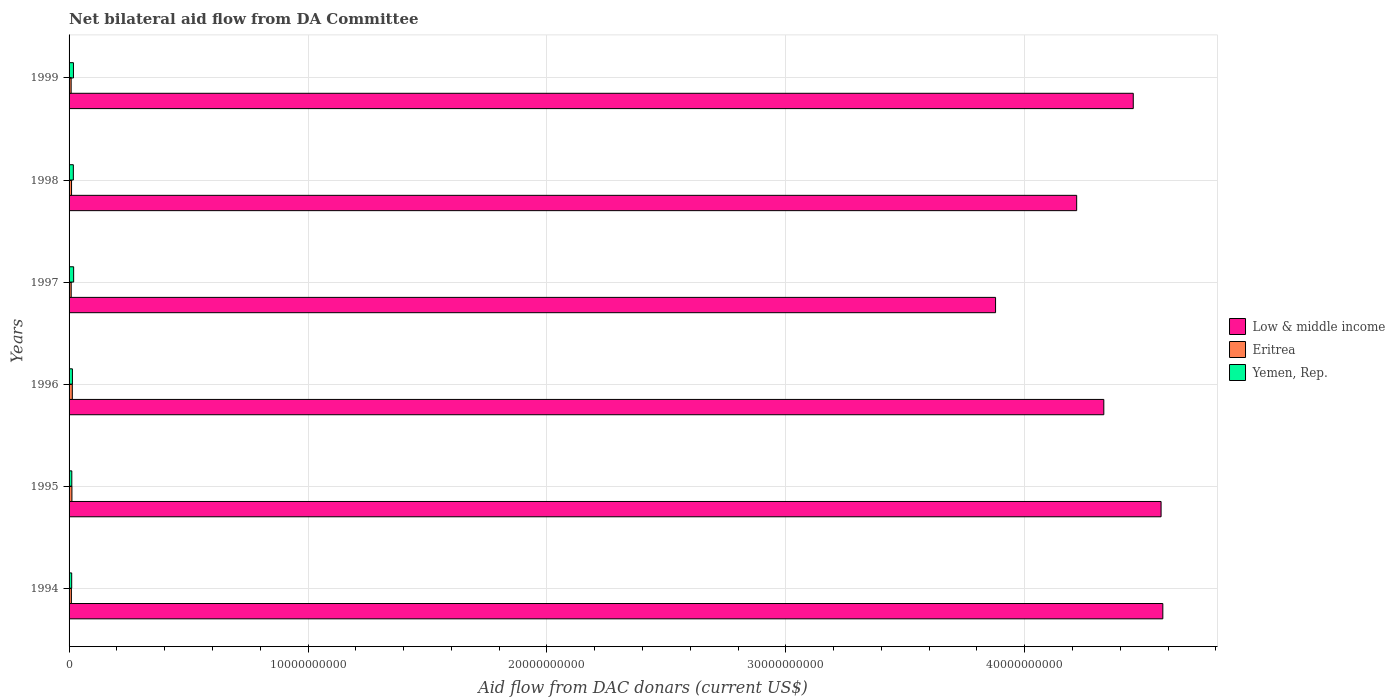How many groups of bars are there?
Offer a very short reply. 6. Are the number of bars on each tick of the Y-axis equal?
Make the answer very short. Yes. How many bars are there on the 6th tick from the top?
Offer a very short reply. 3. What is the label of the 1st group of bars from the top?
Provide a succinct answer. 1999. What is the aid flow in in Eritrea in 1994?
Your answer should be compact. 9.72e+07. Across all years, what is the maximum aid flow in in Eritrea?
Your answer should be very brief. 1.36e+08. Across all years, what is the minimum aid flow in in Eritrea?
Give a very brief answer. 8.65e+07. In which year was the aid flow in in Low & middle income maximum?
Your answer should be very brief. 1994. What is the total aid flow in in Yemen, Rep. in the graph?
Offer a terse response. 9.18e+08. What is the difference between the aid flow in in Low & middle income in 1994 and that in 1998?
Provide a succinct answer. 3.61e+09. What is the difference between the aid flow in in Yemen, Rep. in 1994 and the aid flow in in Eritrea in 1998?
Offer a terse response. 6.26e+06. What is the average aid flow in in Eritrea per year?
Give a very brief answer. 1.05e+08. In the year 1998, what is the difference between the aid flow in in Yemen, Rep. and aid flow in in Eritrea?
Provide a short and direct response. 7.51e+07. In how many years, is the aid flow in in Yemen, Rep. greater than 34000000000 US$?
Provide a succinct answer. 0. What is the ratio of the aid flow in in Eritrea in 1994 to that in 1999?
Your answer should be very brief. 1.12. Is the difference between the aid flow in in Yemen, Rep. in 1995 and 1999 greater than the difference between the aid flow in in Eritrea in 1995 and 1999?
Your response must be concise. No. What is the difference between the highest and the second highest aid flow in in Yemen, Rep.?
Provide a short and direct response. 7.62e+06. What is the difference between the highest and the lowest aid flow in in Yemen, Rep.?
Keep it short and to the point. 8.14e+07. In how many years, is the aid flow in in Low & middle income greater than the average aid flow in in Low & middle income taken over all years?
Your answer should be very brief. 3. Is the sum of the aid flow in in Yemen, Rep. in 1997 and 1998 greater than the maximum aid flow in in Low & middle income across all years?
Your answer should be very brief. No. What does the 2nd bar from the top in 1995 represents?
Give a very brief answer. Eritrea. What does the 3rd bar from the bottom in 1997 represents?
Make the answer very short. Yemen, Rep. How many years are there in the graph?
Offer a very short reply. 6. Does the graph contain grids?
Provide a succinct answer. Yes. How many legend labels are there?
Your response must be concise. 3. What is the title of the graph?
Give a very brief answer. Net bilateral aid flow from DA Committee. What is the label or title of the X-axis?
Ensure brevity in your answer.  Aid flow from DAC donars (current US$). What is the label or title of the Y-axis?
Provide a short and direct response. Years. What is the Aid flow from DAC donars (current US$) in Low & middle income in 1994?
Offer a terse response. 4.58e+1. What is the Aid flow from DAC donars (current US$) of Eritrea in 1994?
Provide a short and direct response. 9.72e+07. What is the Aid flow from DAC donars (current US$) of Yemen, Rep. in 1994?
Make the answer very short. 1.10e+08. What is the Aid flow from DAC donars (current US$) of Low & middle income in 1995?
Provide a short and direct response. 4.57e+1. What is the Aid flow from DAC donars (current US$) in Eritrea in 1995?
Ensure brevity in your answer.  1.19e+08. What is the Aid flow from DAC donars (current US$) of Yemen, Rep. in 1995?
Provide a succinct answer. 1.15e+08. What is the Aid flow from DAC donars (current US$) of Low & middle income in 1996?
Make the answer very short. 4.33e+1. What is the Aid flow from DAC donars (current US$) of Eritrea in 1996?
Make the answer very short. 1.36e+08. What is the Aid flow from DAC donars (current US$) of Yemen, Rep. in 1996?
Make the answer very short. 1.40e+08. What is the Aid flow from DAC donars (current US$) of Low & middle income in 1997?
Give a very brief answer. 3.88e+1. What is the Aid flow from DAC donars (current US$) in Eritrea in 1997?
Give a very brief answer. 8.83e+07. What is the Aid flow from DAC donars (current US$) of Yemen, Rep. in 1997?
Your response must be concise. 1.91e+08. What is the Aid flow from DAC donars (current US$) of Low & middle income in 1998?
Keep it short and to the point. 4.22e+1. What is the Aid flow from DAC donars (current US$) of Eritrea in 1998?
Give a very brief answer. 1.04e+08. What is the Aid flow from DAC donars (current US$) in Yemen, Rep. in 1998?
Your response must be concise. 1.79e+08. What is the Aid flow from DAC donars (current US$) in Low & middle income in 1999?
Offer a terse response. 4.45e+1. What is the Aid flow from DAC donars (current US$) of Eritrea in 1999?
Offer a very short reply. 8.65e+07. What is the Aid flow from DAC donars (current US$) of Yemen, Rep. in 1999?
Offer a terse response. 1.84e+08. Across all years, what is the maximum Aid flow from DAC donars (current US$) of Low & middle income?
Offer a very short reply. 4.58e+1. Across all years, what is the maximum Aid flow from DAC donars (current US$) of Eritrea?
Ensure brevity in your answer.  1.36e+08. Across all years, what is the maximum Aid flow from DAC donars (current US$) in Yemen, Rep.?
Keep it short and to the point. 1.91e+08. Across all years, what is the minimum Aid flow from DAC donars (current US$) of Low & middle income?
Ensure brevity in your answer.  3.88e+1. Across all years, what is the minimum Aid flow from DAC donars (current US$) in Eritrea?
Offer a terse response. 8.65e+07. Across all years, what is the minimum Aid flow from DAC donars (current US$) in Yemen, Rep.?
Your response must be concise. 1.10e+08. What is the total Aid flow from DAC donars (current US$) of Low & middle income in the graph?
Keep it short and to the point. 2.60e+11. What is the total Aid flow from DAC donars (current US$) of Eritrea in the graph?
Your answer should be very brief. 6.31e+08. What is the total Aid flow from DAC donars (current US$) of Yemen, Rep. in the graph?
Offer a terse response. 9.18e+08. What is the difference between the Aid flow from DAC donars (current US$) in Low & middle income in 1994 and that in 1995?
Offer a terse response. 7.27e+07. What is the difference between the Aid flow from DAC donars (current US$) in Eritrea in 1994 and that in 1995?
Give a very brief answer. -2.22e+07. What is the difference between the Aid flow from DAC donars (current US$) in Yemen, Rep. in 1994 and that in 1995?
Provide a short and direct response. -4.75e+06. What is the difference between the Aid flow from DAC donars (current US$) in Low & middle income in 1994 and that in 1996?
Offer a very short reply. 2.47e+09. What is the difference between the Aid flow from DAC donars (current US$) in Eritrea in 1994 and that in 1996?
Offer a very short reply. -3.84e+07. What is the difference between the Aid flow from DAC donars (current US$) in Yemen, Rep. in 1994 and that in 1996?
Give a very brief answer. -3.02e+07. What is the difference between the Aid flow from DAC donars (current US$) in Low & middle income in 1994 and that in 1997?
Provide a short and direct response. 7.00e+09. What is the difference between the Aid flow from DAC donars (current US$) in Eritrea in 1994 and that in 1997?
Keep it short and to the point. 8.90e+06. What is the difference between the Aid flow from DAC donars (current US$) in Yemen, Rep. in 1994 and that in 1997?
Offer a very short reply. -8.14e+07. What is the difference between the Aid flow from DAC donars (current US$) in Low & middle income in 1994 and that in 1998?
Your answer should be very brief. 3.61e+09. What is the difference between the Aid flow from DAC donars (current US$) of Eritrea in 1994 and that in 1998?
Your answer should be very brief. -6.32e+06. What is the difference between the Aid flow from DAC donars (current US$) of Yemen, Rep. in 1994 and that in 1998?
Your response must be concise. -6.89e+07. What is the difference between the Aid flow from DAC donars (current US$) of Low & middle income in 1994 and that in 1999?
Make the answer very short. 1.24e+09. What is the difference between the Aid flow from DAC donars (current US$) of Eritrea in 1994 and that in 1999?
Your response must be concise. 1.07e+07. What is the difference between the Aid flow from DAC donars (current US$) of Yemen, Rep. in 1994 and that in 1999?
Provide a short and direct response. -7.38e+07. What is the difference between the Aid flow from DAC donars (current US$) of Low & middle income in 1995 and that in 1996?
Your answer should be compact. 2.40e+09. What is the difference between the Aid flow from DAC donars (current US$) of Eritrea in 1995 and that in 1996?
Offer a terse response. -1.62e+07. What is the difference between the Aid flow from DAC donars (current US$) in Yemen, Rep. in 1995 and that in 1996?
Your answer should be very brief. -2.54e+07. What is the difference between the Aid flow from DAC donars (current US$) in Low & middle income in 1995 and that in 1997?
Offer a very short reply. 6.93e+09. What is the difference between the Aid flow from DAC donars (current US$) in Eritrea in 1995 and that in 1997?
Provide a short and direct response. 3.12e+07. What is the difference between the Aid flow from DAC donars (current US$) in Yemen, Rep. in 1995 and that in 1997?
Your answer should be very brief. -7.67e+07. What is the difference between the Aid flow from DAC donars (current US$) of Low & middle income in 1995 and that in 1998?
Provide a short and direct response. 3.53e+09. What is the difference between the Aid flow from DAC donars (current US$) of Eritrea in 1995 and that in 1998?
Your answer should be compact. 1.59e+07. What is the difference between the Aid flow from DAC donars (current US$) in Yemen, Rep. in 1995 and that in 1998?
Provide a succinct answer. -6.41e+07. What is the difference between the Aid flow from DAC donars (current US$) of Low & middle income in 1995 and that in 1999?
Your response must be concise. 1.16e+09. What is the difference between the Aid flow from DAC donars (current US$) in Eritrea in 1995 and that in 1999?
Offer a terse response. 3.30e+07. What is the difference between the Aid flow from DAC donars (current US$) of Yemen, Rep. in 1995 and that in 1999?
Make the answer very short. -6.91e+07. What is the difference between the Aid flow from DAC donars (current US$) of Low & middle income in 1996 and that in 1997?
Keep it short and to the point. 4.53e+09. What is the difference between the Aid flow from DAC donars (current US$) in Eritrea in 1996 and that in 1997?
Give a very brief answer. 4.73e+07. What is the difference between the Aid flow from DAC donars (current US$) of Yemen, Rep. in 1996 and that in 1997?
Ensure brevity in your answer.  -5.13e+07. What is the difference between the Aid flow from DAC donars (current US$) in Low & middle income in 1996 and that in 1998?
Ensure brevity in your answer.  1.14e+09. What is the difference between the Aid flow from DAC donars (current US$) in Eritrea in 1996 and that in 1998?
Provide a succinct answer. 3.21e+07. What is the difference between the Aid flow from DAC donars (current US$) in Yemen, Rep. in 1996 and that in 1998?
Provide a succinct answer. -3.87e+07. What is the difference between the Aid flow from DAC donars (current US$) of Low & middle income in 1996 and that in 1999?
Make the answer very short. -1.23e+09. What is the difference between the Aid flow from DAC donars (current US$) of Eritrea in 1996 and that in 1999?
Offer a terse response. 4.91e+07. What is the difference between the Aid flow from DAC donars (current US$) of Yemen, Rep. in 1996 and that in 1999?
Your answer should be very brief. -4.37e+07. What is the difference between the Aid flow from DAC donars (current US$) of Low & middle income in 1997 and that in 1998?
Offer a very short reply. -3.39e+09. What is the difference between the Aid flow from DAC donars (current US$) of Eritrea in 1997 and that in 1998?
Offer a terse response. -1.52e+07. What is the difference between the Aid flow from DAC donars (current US$) in Yemen, Rep. in 1997 and that in 1998?
Provide a succinct answer. 1.26e+07. What is the difference between the Aid flow from DAC donars (current US$) of Low & middle income in 1997 and that in 1999?
Your answer should be compact. -5.76e+09. What is the difference between the Aid flow from DAC donars (current US$) in Eritrea in 1997 and that in 1999?
Keep it short and to the point. 1.83e+06. What is the difference between the Aid flow from DAC donars (current US$) of Yemen, Rep. in 1997 and that in 1999?
Keep it short and to the point. 7.62e+06. What is the difference between the Aid flow from DAC donars (current US$) of Low & middle income in 1998 and that in 1999?
Give a very brief answer. -2.37e+09. What is the difference between the Aid flow from DAC donars (current US$) of Eritrea in 1998 and that in 1999?
Ensure brevity in your answer.  1.70e+07. What is the difference between the Aid flow from DAC donars (current US$) in Yemen, Rep. in 1998 and that in 1999?
Keep it short and to the point. -4.94e+06. What is the difference between the Aid flow from DAC donars (current US$) of Low & middle income in 1994 and the Aid flow from DAC donars (current US$) of Eritrea in 1995?
Your answer should be very brief. 4.57e+1. What is the difference between the Aid flow from DAC donars (current US$) of Low & middle income in 1994 and the Aid flow from DAC donars (current US$) of Yemen, Rep. in 1995?
Your answer should be compact. 4.57e+1. What is the difference between the Aid flow from DAC donars (current US$) in Eritrea in 1994 and the Aid flow from DAC donars (current US$) in Yemen, Rep. in 1995?
Offer a very short reply. -1.73e+07. What is the difference between the Aid flow from DAC donars (current US$) of Low & middle income in 1994 and the Aid flow from DAC donars (current US$) of Eritrea in 1996?
Your response must be concise. 4.56e+1. What is the difference between the Aid flow from DAC donars (current US$) of Low & middle income in 1994 and the Aid flow from DAC donars (current US$) of Yemen, Rep. in 1996?
Provide a succinct answer. 4.56e+1. What is the difference between the Aid flow from DAC donars (current US$) in Eritrea in 1994 and the Aid flow from DAC donars (current US$) in Yemen, Rep. in 1996?
Your response must be concise. -4.27e+07. What is the difference between the Aid flow from DAC donars (current US$) in Low & middle income in 1994 and the Aid flow from DAC donars (current US$) in Eritrea in 1997?
Keep it short and to the point. 4.57e+1. What is the difference between the Aid flow from DAC donars (current US$) of Low & middle income in 1994 and the Aid flow from DAC donars (current US$) of Yemen, Rep. in 1997?
Your answer should be very brief. 4.56e+1. What is the difference between the Aid flow from DAC donars (current US$) of Eritrea in 1994 and the Aid flow from DAC donars (current US$) of Yemen, Rep. in 1997?
Provide a short and direct response. -9.40e+07. What is the difference between the Aid flow from DAC donars (current US$) in Low & middle income in 1994 and the Aid flow from DAC donars (current US$) in Eritrea in 1998?
Your response must be concise. 4.57e+1. What is the difference between the Aid flow from DAC donars (current US$) of Low & middle income in 1994 and the Aid flow from DAC donars (current US$) of Yemen, Rep. in 1998?
Keep it short and to the point. 4.56e+1. What is the difference between the Aid flow from DAC donars (current US$) of Eritrea in 1994 and the Aid flow from DAC donars (current US$) of Yemen, Rep. in 1998?
Offer a terse response. -8.14e+07. What is the difference between the Aid flow from DAC donars (current US$) in Low & middle income in 1994 and the Aid flow from DAC donars (current US$) in Eritrea in 1999?
Make the answer very short. 4.57e+1. What is the difference between the Aid flow from DAC donars (current US$) of Low & middle income in 1994 and the Aid flow from DAC donars (current US$) of Yemen, Rep. in 1999?
Your response must be concise. 4.56e+1. What is the difference between the Aid flow from DAC donars (current US$) in Eritrea in 1994 and the Aid flow from DAC donars (current US$) in Yemen, Rep. in 1999?
Your answer should be very brief. -8.64e+07. What is the difference between the Aid flow from DAC donars (current US$) of Low & middle income in 1995 and the Aid flow from DAC donars (current US$) of Eritrea in 1996?
Give a very brief answer. 4.56e+1. What is the difference between the Aid flow from DAC donars (current US$) of Low & middle income in 1995 and the Aid flow from DAC donars (current US$) of Yemen, Rep. in 1996?
Your answer should be compact. 4.56e+1. What is the difference between the Aid flow from DAC donars (current US$) in Eritrea in 1995 and the Aid flow from DAC donars (current US$) in Yemen, Rep. in 1996?
Your answer should be very brief. -2.05e+07. What is the difference between the Aid flow from DAC donars (current US$) of Low & middle income in 1995 and the Aid flow from DAC donars (current US$) of Eritrea in 1997?
Your response must be concise. 4.56e+1. What is the difference between the Aid flow from DAC donars (current US$) in Low & middle income in 1995 and the Aid flow from DAC donars (current US$) in Yemen, Rep. in 1997?
Your answer should be very brief. 4.55e+1. What is the difference between the Aid flow from DAC donars (current US$) in Eritrea in 1995 and the Aid flow from DAC donars (current US$) in Yemen, Rep. in 1997?
Provide a succinct answer. -7.18e+07. What is the difference between the Aid flow from DAC donars (current US$) in Low & middle income in 1995 and the Aid flow from DAC donars (current US$) in Eritrea in 1998?
Offer a terse response. 4.56e+1. What is the difference between the Aid flow from DAC donars (current US$) in Low & middle income in 1995 and the Aid flow from DAC donars (current US$) in Yemen, Rep. in 1998?
Give a very brief answer. 4.55e+1. What is the difference between the Aid flow from DAC donars (current US$) of Eritrea in 1995 and the Aid flow from DAC donars (current US$) of Yemen, Rep. in 1998?
Your answer should be very brief. -5.92e+07. What is the difference between the Aid flow from DAC donars (current US$) in Low & middle income in 1995 and the Aid flow from DAC donars (current US$) in Eritrea in 1999?
Offer a terse response. 4.56e+1. What is the difference between the Aid flow from DAC donars (current US$) of Low & middle income in 1995 and the Aid flow from DAC donars (current US$) of Yemen, Rep. in 1999?
Keep it short and to the point. 4.55e+1. What is the difference between the Aid flow from DAC donars (current US$) of Eritrea in 1995 and the Aid flow from DAC donars (current US$) of Yemen, Rep. in 1999?
Keep it short and to the point. -6.41e+07. What is the difference between the Aid flow from DAC donars (current US$) in Low & middle income in 1996 and the Aid flow from DAC donars (current US$) in Eritrea in 1997?
Offer a very short reply. 4.32e+1. What is the difference between the Aid flow from DAC donars (current US$) in Low & middle income in 1996 and the Aid flow from DAC donars (current US$) in Yemen, Rep. in 1997?
Your response must be concise. 4.31e+1. What is the difference between the Aid flow from DAC donars (current US$) in Eritrea in 1996 and the Aid flow from DAC donars (current US$) in Yemen, Rep. in 1997?
Provide a short and direct response. -5.56e+07. What is the difference between the Aid flow from DAC donars (current US$) of Low & middle income in 1996 and the Aid flow from DAC donars (current US$) of Eritrea in 1998?
Provide a short and direct response. 4.32e+1. What is the difference between the Aid flow from DAC donars (current US$) in Low & middle income in 1996 and the Aid flow from DAC donars (current US$) in Yemen, Rep. in 1998?
Your answer should be compact. 4.31e+1. What is the difference between the Aid flow from DAC donars (current US$) in Eritrea in 1996 and the Aid flow from DAC donars (current US$) in Yemen, Rep. in 1998?
Give a very brief answer. -4.30e+07. What is the difference between the Aid flow from DAC donars (current US$) in Low & middle income in 1996 and the Aid flow from DAC donars (current US$) in Eritrea in 1999?
Keep it short and to the point. 4.32e+1. What is the difference between the Aid flow from DAC donars (current US$) of Low & middle income in 1996 and the Aid flow from DAC donars (current US$) of Yemen, Rep. in 1999?
Keep it short and to the point. 4.31e+1. What is the difference between the Aid flow from DAC donars (current US$) in Eritrea in 1996 and the Aid flow from DAC donars (current US$) in Yemen, Rep. in 1999?
Offer a terse response. -4.80e+07. What is the difference between the Aid flow from DAC donars (current US$) of Low & middle income in 1997 and the Aid flow from DAC donars (current US$) of Eritrea in 1998?
Make the answer very short. 3.87e+1. What is the difference between the Aid flow from DAC donars (current US$) of Low & middle income in 1997 and the Aid flow from DAC donars (current US$) of Yemen, Rep. in 1998?
Keep it short and to the point. 3.86e+1. What is the difference between the Aid flow from DAC donars (current US$) of Eritrea in 1997 and the Aid flow from DAC donars (current US$) of Yemen, Rep. in 1998?
Keep it short and to the point. -9.04e+07. What is the difference between the Aid flow from DAC donars (current US$) of Low & middle income in 1997 and the Aid flow from DAC donars (current US$) of Eritrea in 1999?
Give a very brief answer. 3.87e+1. What is the difference between the Aid flow from DAC donars (current US$) of Low & middle income in 1997 and the Aid flow from DAC donars (current US$) of Yemen, Rep. in 1999?
Keep it short and to the point. 3.86e+1. What is the difference between the Aid flow from DAC donars (current US$) of Eritrea in 1997 and the Aid flow from DAC donars (current US$) of Yemen, Rep. in 1999?
Your answer should be compact. -9.53e+07. What is the difference between the Aid flow from DAC donars (current US$) of Low & middle income in 1998 and the Aid flow from DAC donars (current US$) of Eritrea in 1999?
Offer a terse response. 4.21e+1. What is the difference between the Aid flow from DAC donars (current US$) in Low & middle income in 1998 and the Aid flow from DAC donars (current US$) in Yemen, Rep. in 1999?
Provide a succinct answer. 4.20e+1. What is the difference between the Aid flow from DAC donars (current US$) in Eritrea in 1998 and the Aid flow from DAC donars (current US$) in Yemen, Rep. in 1999?
Your response must be concise. -8.01e+07. What is the average Aid flow from DAC donars (current US$) of Low & middle income per year?
Your response must be concise. 4.34e+1. What is the average Aid flow from DAC donars (current US$) of Eritrea per year?
Offer a terse response. 1.05e+08. What is the average Aid flow from DAC donars (current US$) in Yemen, Rep. per year?
Offer a terse response. 1.53e+08. In the year 1994, what is the difference between the Aid flow from DAC donars (current US$) in Low & middle income and Aid flow from DAC donars (current US$) in Eritrea?
Provide a short and direct response. 4.57e+1. In the year 1994, what is the difference between the Aid flow from DAC donars (current US$) of Low & middle income and Aid flow from DAC donars (current US$) of Yemen, Rep.?
Offer a very short reply. 4.57e+1. In the year 1994, what is the difference between the Aid flow from DAC donars (current US$) of Eritrea and Aid flow from DAC donars (current US$) of Yemen, Rep.?
Provide a succinct answer. -1.26e+07. In the year 1995, what is the difference between the Aid flow from DAC donars (current US$) in Low & middle income and Aid flow from DAC donars (current US$) in Eritrea?
Make the answer very short. 4.56e+1. In the year 1995, what is the difference between the Aid flow from DAC donars (current US$) of Low & middle income and Aid flow from DAC donars (current US$) of Yemen, Rep.?
Offer a terse response. 4.56e+1. In the year 1995, what is the difference between the Aid flow from DAC donars (current US$) in Eritrea and Aid flow from DAC donars (current US$) in Yemen, Rep.?
Your response must be concise. 4.92e+06. In the year 1996, what is the difference between the Aid flow from DAC donars (current US$) of Low & middle income and Aid flow from DAC donars (current US$) of Eritrea?
Offer a very short reply. 4.32e+1. In the year 1996, what is the difference between the Aid flow from DAC donars (current US$) in Low & middle income and Aid flow from DAC donars (current US$) in Yemen, Rep.?
Give a very brief answer. 4.32e+1. In the year 1996, what is the difference between the Aid flow from DAC donars (current US$) of Eritrea and Aid flow from DAC donars (current US$) of Yemen, Rep.?
Keep it short and to the point. -4.32e+06. In the year 1997, what is the difference between the Aid flow from DAC donars (current US$) of Low & middle income and Aid flow from DAC donars (current US$) of Eritrea?
Ensure brevity in your answer.  3.87e+1. In the year 1997, what is the difference between the Aid flow from DAC donars (current US$) of Low & middle income and Aid flow from DAC donars (current US$) of Yemen, Rep.?
Make the answer very short. 3.86e+1. In the year 1997, what is the difference between the Aid flow from DAC donars (current US$) in Eritrea and Aid flow from DAC donars (current US$) in Yemen, Rep.?
Your answer should be very brief. -1.03e+08. In the year 1998, what is the difference between the Aid flow from DAC donars (current US$) in Low & middle income and Aid flow from DAC donars (current US$) in Eritrea?
Ensure brevity in your answer.  4.21e+1. In the year 1998, what is the difference between the Aid flow from DAC donars (current US$) of Low & middle income and Aid flow from DAC donars (current US$) of Yemen, Rep.?
Offer a terse response. 4.20e+1. In the year 1998, what is the difference between the Aid flow from DAC donars (current US$) of Eritrea and Aid flow from DAC donars (current US$) of Yemen, Rep.?
Keep it short and to the point. -7.51e+07. In the year 1999, what is the difference between the Aid flow from DAC donars (current US$) of Low & middle income and Aid flow from DAC donars (current US$) of Eritrea?
Give a very brief answer. 4.45e+1. In the year 1999, what is the difference between the Aid flow from DAC donars (current US$) in Low & middle income and Aid flow from DAC donars (current US$) in Yemen, Rep.?
Ensure brevity in your answer.  4.44e+1. In the year 1999, what is the difference between the Aid flow from DAC donars (current US$) of Eritrea and Aid flow from DAC donars (current US$) of Yemen, Rep.?
Provide a short and direct response. -9.71e+07. What is the ratio of the Aid flow from DAC donars (current US$) of Low & middle income in 1994 to that in 1995?
Make the answer very short. 1. What is the ratio of the Aid flow from DAC donars (current US$) of Eritrea in 1994 to that in 1995?
Ensure brevity in your answer.  0.81. What is the ratio of the Aid flow from DAC donars (current US$) in Yemen, Rep. in 1994 to that in 1995?
Ensure brevity in your answer.  0.96. What is the ratio of the Aid flow from DAC donars (current US$) in Low & middle income in 1994 to that in 1996?
Give a very brief answer. 1.06. What is the ratio of the Aid flow from DAC donars (current US$) in Eritrea in 1994 to that in 1996?
Ensure brevity in your answer.  0.72. What is the ratio of the Aid flow from DAC donars (current US$) of Yemen, Rep. in 1994 to that in 1996?
Your answer should be compact. 0.78. What is the ratio of the Aid flow from DAC donars (current US$) of Low & middle income in 1994 to that in 1997?
Your answer should be compact. 1.18. What is the ratio of the Aid flow from DAC donars (current US$) of Eritrea in 1994 to that in 1997?
Provide a short and direct response. 1.1. What is the ratio of the Aid flow from DAC donars (current US$) in Yemen, Rep. in 1994 to that in 1997?
Ensure brevity in your answer.  0.57. What is the ratio of the Aid flow from DAC donars (current US$) of Low & middle income in 1994 to that in 1998?
Your answer should be compact. 1.09. What is the ratio of the Aid flow from DAC donars (current US$) in Eritrea in 1994 to that in 1998?
Make the answer very short. 0.94. What is the ratio of the Aid flow from DAC donars (current US$) of Yemen, Rep. in 1994 to that in 1998?
Keep it short and to the point. 0.61. What is the ratio of the Aid flow from DAC donars (current US$) of Low & middle income in 1994 to that in 1999?
Your answer should be compact. 1.03. What is the ratio of the Aid flow from DAC donars (current US$) in Eritrea in 1994 to that in 1999?
Make the answer very short. 1.12. What is the ratio of the Aid flow from DAC donars (current US$) in Yemen, Rep. in 1994 to that in 1999?
Give a very brief answer. 0.6. What is the ratio of the Aid flow from DAC donars (current US$) in Low & middle income in 1995 to that in 1996?
Offer a terse response. 1.06. What is the ratio of the Aid flow from DAC donars (current US$) of Eritrea in 1995 to that in 1996?
Your answer should be compact. 0.88. What is the ratio of the Aid flow from DAC donars (current US$) of Yemen, Rep. in 1995 to that in 1996?
Provide a short and direct response. 0.82. What is the ratio of the Aid flow from DAC donars (current US$) in Low & middle income in 1995 to that in 1997?
Offer a very short reply. 1.18. What is the ratio of the Aid flow from DAC donars (current US$) in Eritrea in 1995 to that in 1997?
Provide a succinct answer. 1.35. What is the ratio of the Aid flow from DAC donars (current US$) in Yemen, Rep. in 1995 to that in 1997?
Your response must be concise. 0.6. What is the ratio of the Aid flow from DAC donars (current US$) in Low & middle income in 1995 to that in 1998?
Provide a succinct answer. 1.08. What is the ratio of the Aid flow from DAC donars (current US$) of Eritrea in 1995 to that in 1998?
Provide a short and direct response. 1.15. What is the ratio of the Aid flow from DAC donars (current US$) of Yemen, Rep. in 1995 to that in 1998?
Make the answer very short. 0.64. What is the ratio of the Aid flow from DAC donars (current US$) in Low & middle income in 1995 to that in 1999?
Your answer should be very brief. 1.03. What is the ratio of the Aid flow from DAC donars (current US$) of Eritrea in 1995 to that in 1999?
Provide a succinct answer. 1.38. What is the ratio of the Aid flow from DAC donars (current US$) of Yemen, Rep. in 1995 to that in 1999?
Ensure brevity in your answer.  0.62. What is the ratio of the Aid flow from DAC donars (current US$) in Low & middle income in 1996 to that in 1997?
Offer a very short reply. 1.12. What is the ratio of the Aid flow from DAC donars (current US$) in Eritrea in 1996 to that in 1997?
Provide a short and direct response. 1.54. What is the ratio of the Aid flow from DAC donars (current US$) in Yemen, Rep. in 1996 to that in 1997?
Keep it short and to the point. 0.73. What is the ratio of the Aid flow from DAC donars (current US$) in Low & middle income in 1996 to that in 1998?
Make the answer very short. 1.03. What is the ratio of the Aid flow from DAC donars (current US$) in Eritrea in 1996 to that in 1998?
Your answer should be compact. 1.31. What is the ratio of the Aid flow from DAC donars (current US$) in Yemen, Rep. in 1996 to that in 1998?
Your response must be concise. 0.78. What is the ratio of the Aid flow from DAC donars (current US$) in Low & middle income in 1996 to that in 1999?
Your response must be concise. 0.97. What is the ratio of the Aid flow from DAC donars (current US$) of Eritrea in 1996 to that in 1999?
Offer a terse response. 1.57. What is the ratio of the Aid flow from DAC donars (current US$) in Yemen, Rep. in 1996 to that in 1999?
Provide a succinct answer. 0.76. What is the ratio of the Aid flow from DAC donars (current US$) of Low & middle income in 1997 to that in 1998?
Your response must be concise. 0.92. What is the ratio of the Aid flow from DAC donars (current US$) in Eritrea in 1997 to that in 1998?
Make the answer very short. 0.85. What is the ratio of the Aid flow from DAC donars (current US$) in Yemen, Rep. in 1997 to that in 1998?
Make the answer very short. 1.07. What is the ratio of the Aid flow from DAC donars (current US$) in Low & middle income in 1997 to that in 1999?
Offer a terse response. 0.87. What is the ratio of the Aid flow from DAC donars (current US$) of Eritrea in 1997 to that in 1999?
Make the answer very short. 1.02. What is the ratio of the Aid flow from DAC donars (current US$) of Yemen, Rep. in 1997 to that in 1999?
Your answer should be compact. 1.04. What is the ratio of the Aid flow from DAC donars (current US$) of Low & middle income in 1998 to that in 1999?
Your answer should be compact. 0.95. What is the ratio of the Aid flow from DAC donars (current US$) in Eritrea in 1998 to that in 1999?
Offer a terse response. 1.2. What is the ratio of the Aid flow from DAC donars (current US$) in Yemen, Rep. in 1998 to that in 1999?
Your answer should be very brief. 0.97. What is the difference between the highest and the second highest Aid flow from DAC donars (current US$) of Low & middle income?
Keep it short and to the point. 7.27e+07. What is the difference between the highest and the second highest Aid flow from DAC donars (current US$) of Eritrea?
Provide a succinct answer. 1.62e+07. What is the difference between the highest and the second highest Aid flow from DAC donars (current US$) in Yemen, Rep.?
Ensure brevity in your answer.  7.62e+06. What is the difference between the highest and the lowest Aid flow from DAC donars (current US$) in Low & middle income?
Give a very brief answer. 7.00e+09. What is the difference between the highest and the lowest Aid flow from DAC donars (current US$) in Eritrea?
Offer a terse response. 4.91e+07. What is the difference between the highest and the lowest Aid flow from DAC donars (current US$) in Yemen, Rep.?
Make the answer very short. 8.14e+07. 